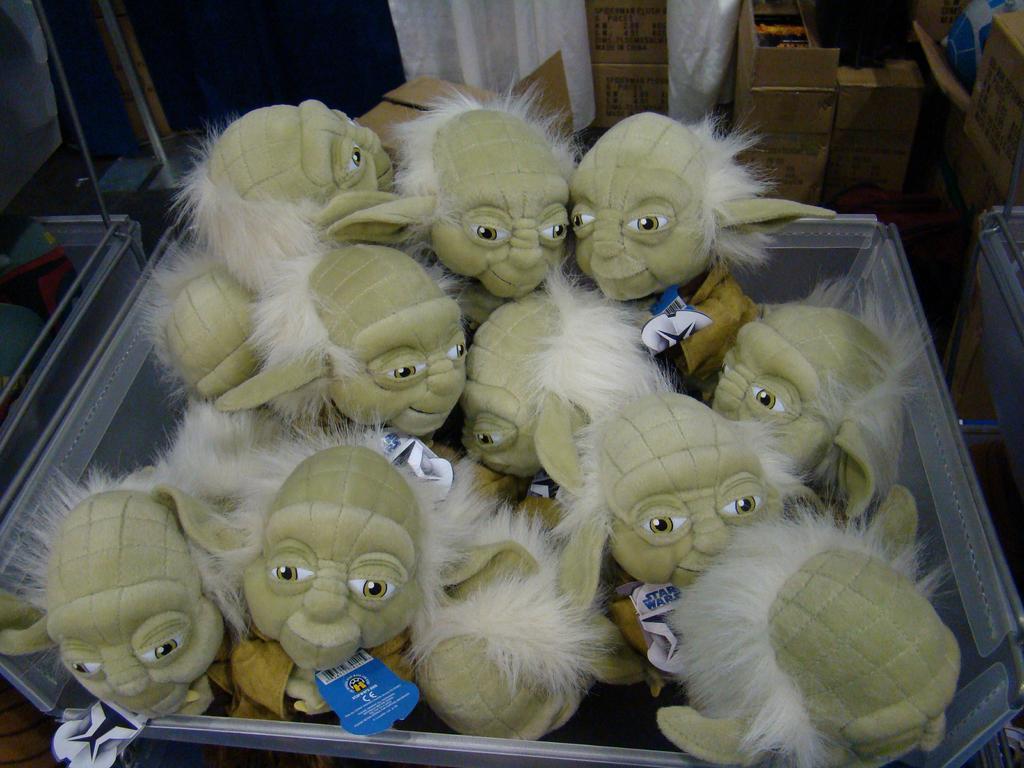Please provide a concise description of this image. There are gray color dolls which are arranged in a basket. In the background, there are boxes arranged in white color curtain, there are other dolls arranged in another box, there are sticks and other objects. 